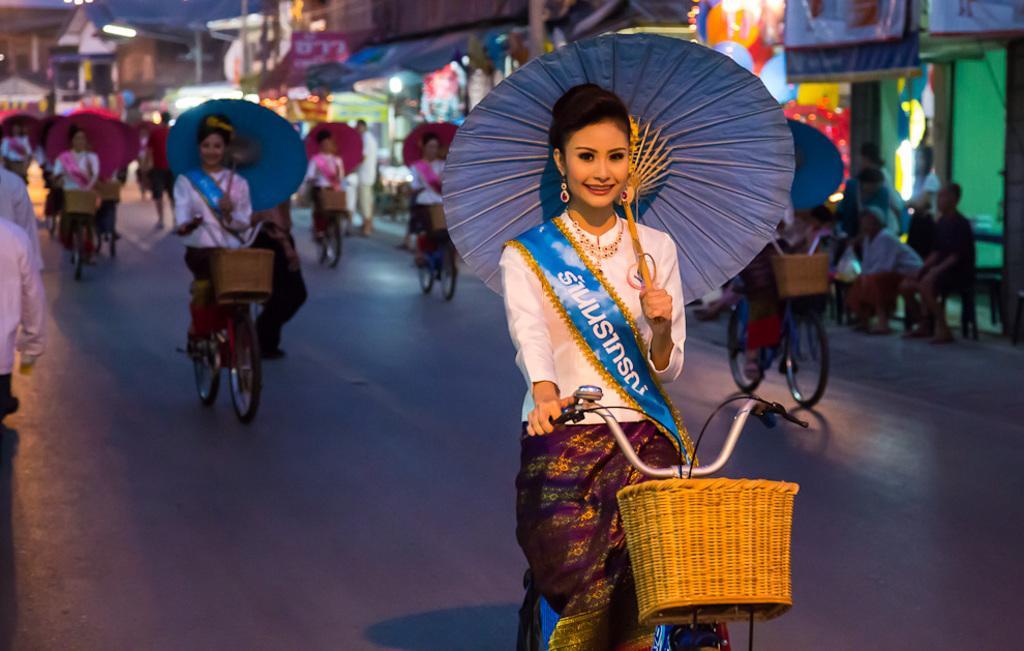In one or two sentences, can you explain what this image depicts? In this image I can see women are sitting on bicycles. These women are holding umbrellas in their hands. In the background I can see buildings, people and some other objects. 